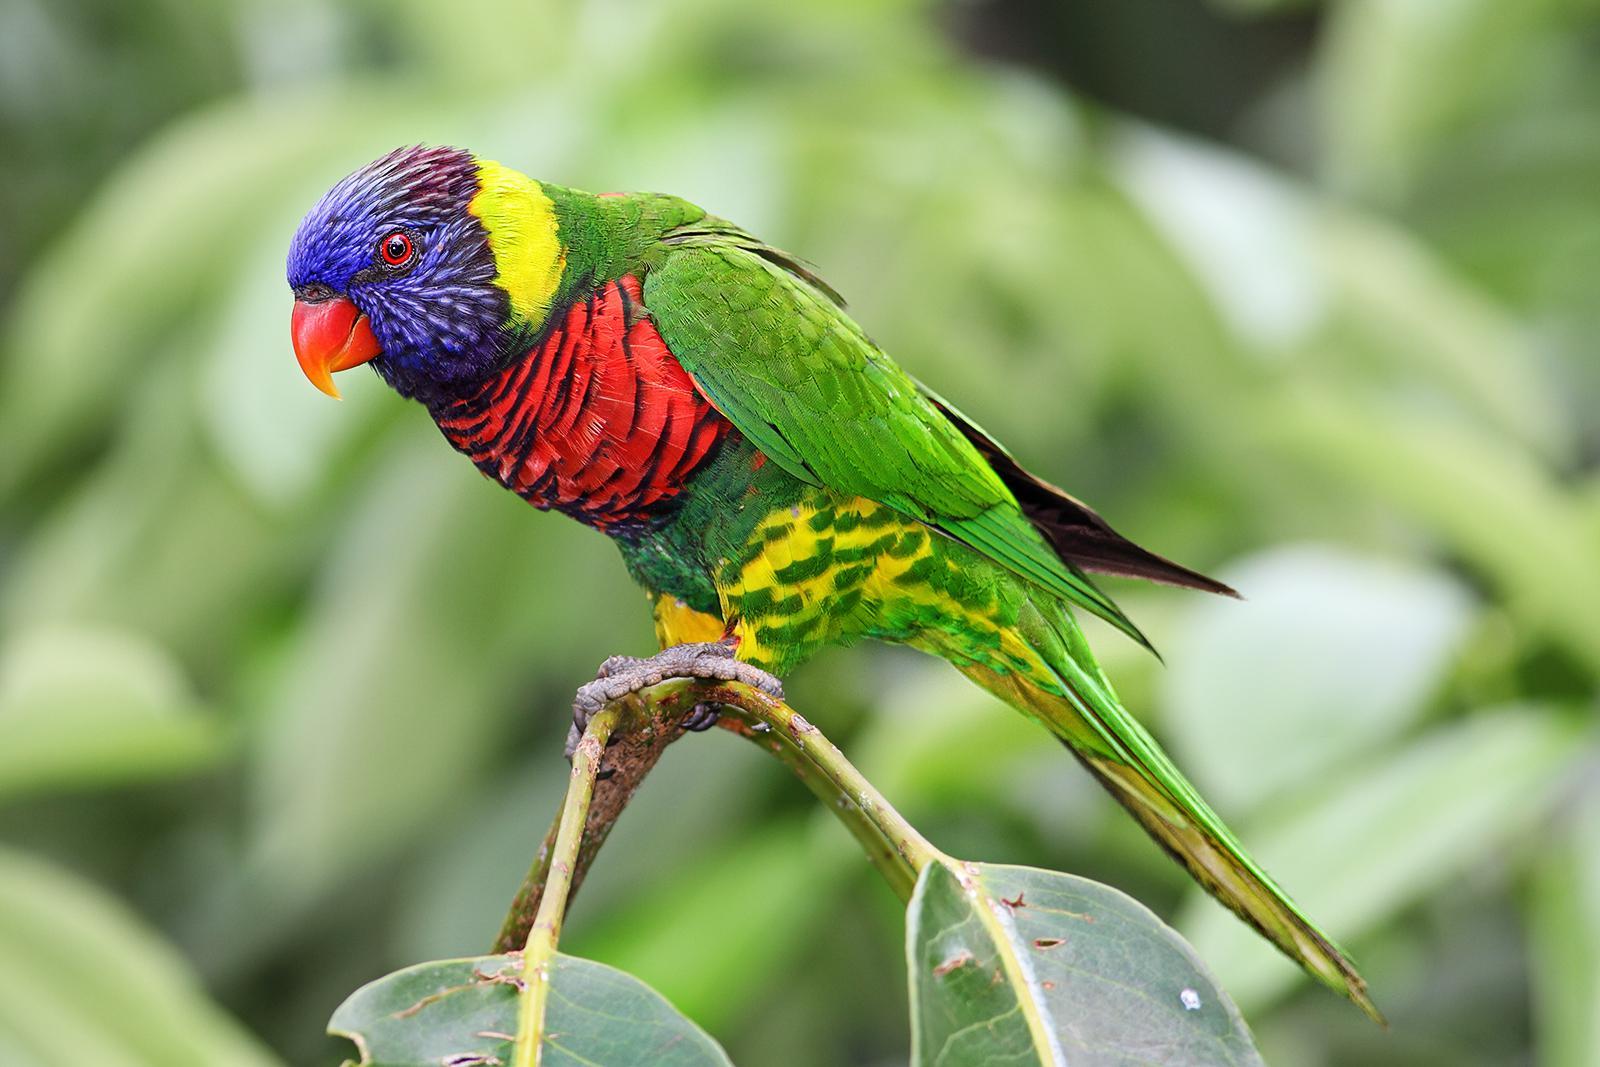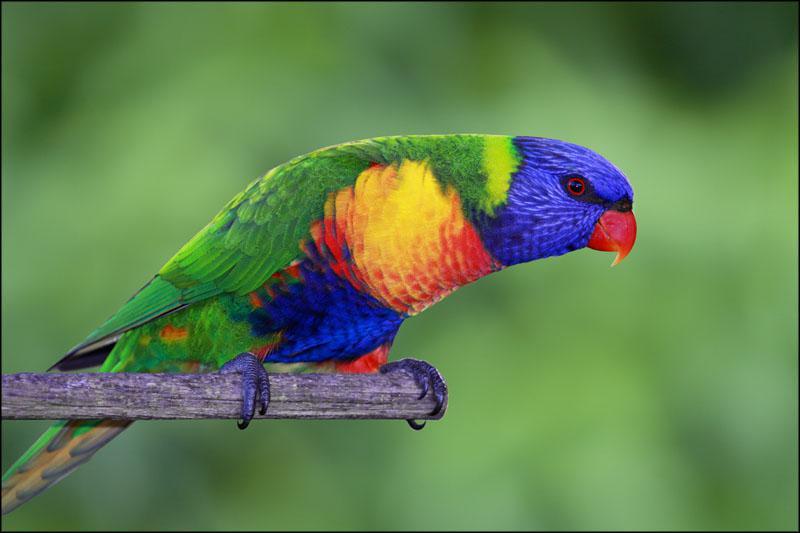The first image is the image on the left, the second image is the image on the right. For the images displayed, is the sentence "There are two birds" factually correct? Answer yes or no. Yes. The first image is the image on the left, the second image is the image on the right. Evaluate the accuracy of this statement regarding the images: "There are two birds". Is it true? Answer yes or no. Yes. 